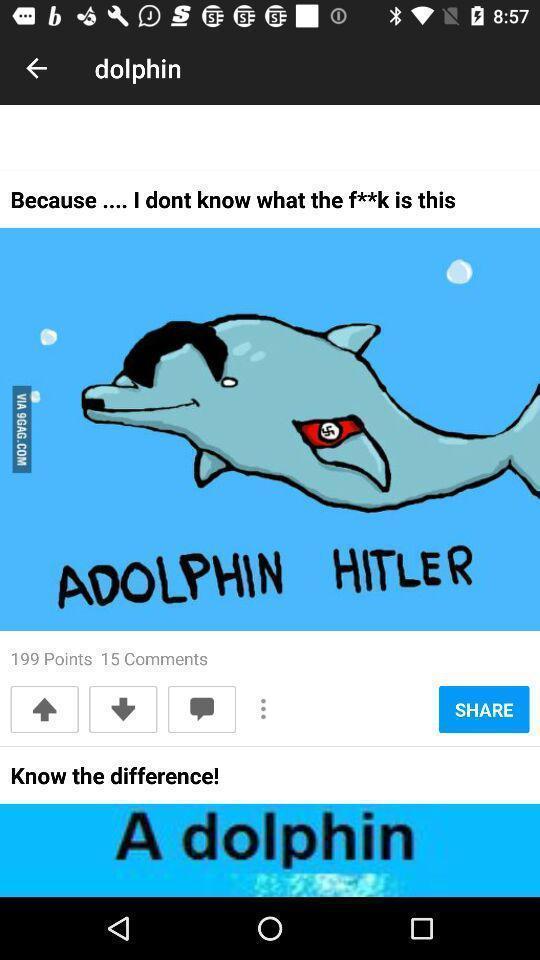What can you discern from this picture? Screen displaying different posts on dolphin. 